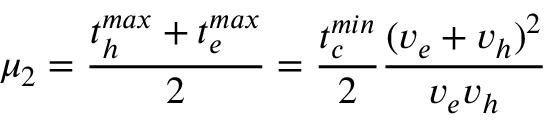<formula> <loc_0><loc_0><loc_500><loc_500>\mu _ { 2 } = \frac { t _ { h } ^ { \max } + t _ { e } ^ { \max } } { 2 } = \frac { t _ { c } ^ { \min } } { 2 } \frac { ( v _ { e } + v _ { h } ) ^ { 2 } } { v _ { e } v _ { h } }</formula> 